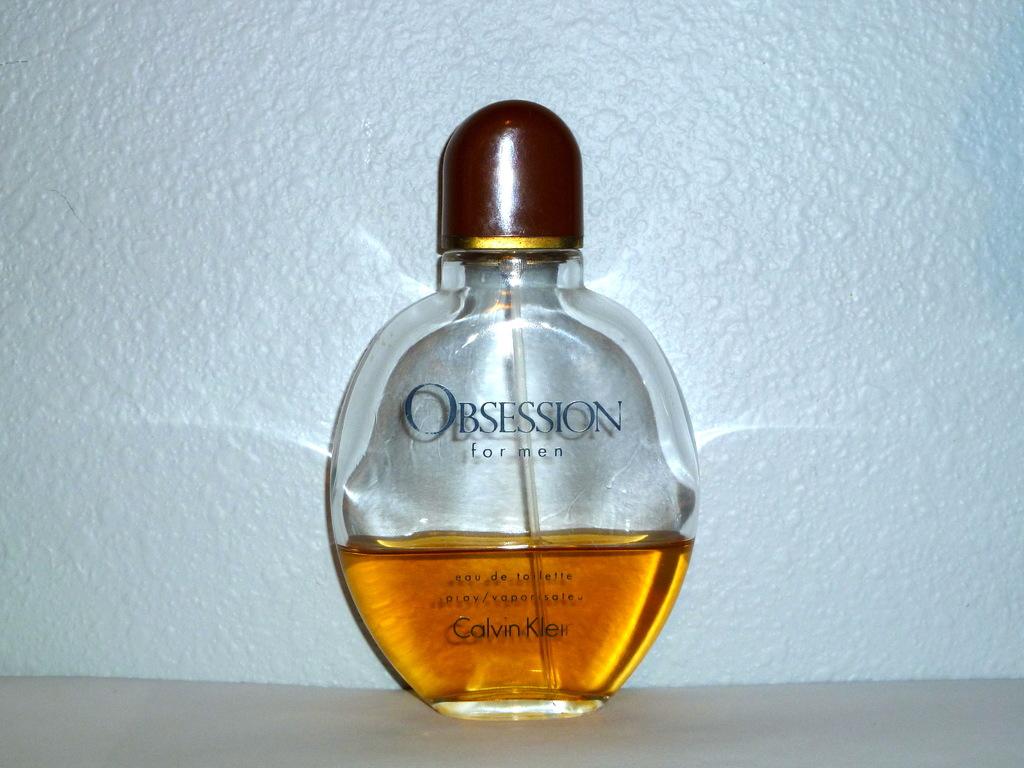What is obsession for?
Offer a very short reply. Men. What is the brand shown at the bottom of the bottle?
Provide a short and direct response. Calvin klein. 